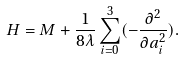Convert formula to latex. <formula><loc_0><loc_0><loc_500><loc_500>H = M + \frac { 1 } { 8 \lambda } \sum _ { i = 0 } ^ { 3 } ( - \frac { \partial ^ { 2 } } { \partial a _ { i } ^ { 2 } } ) .</formula> 